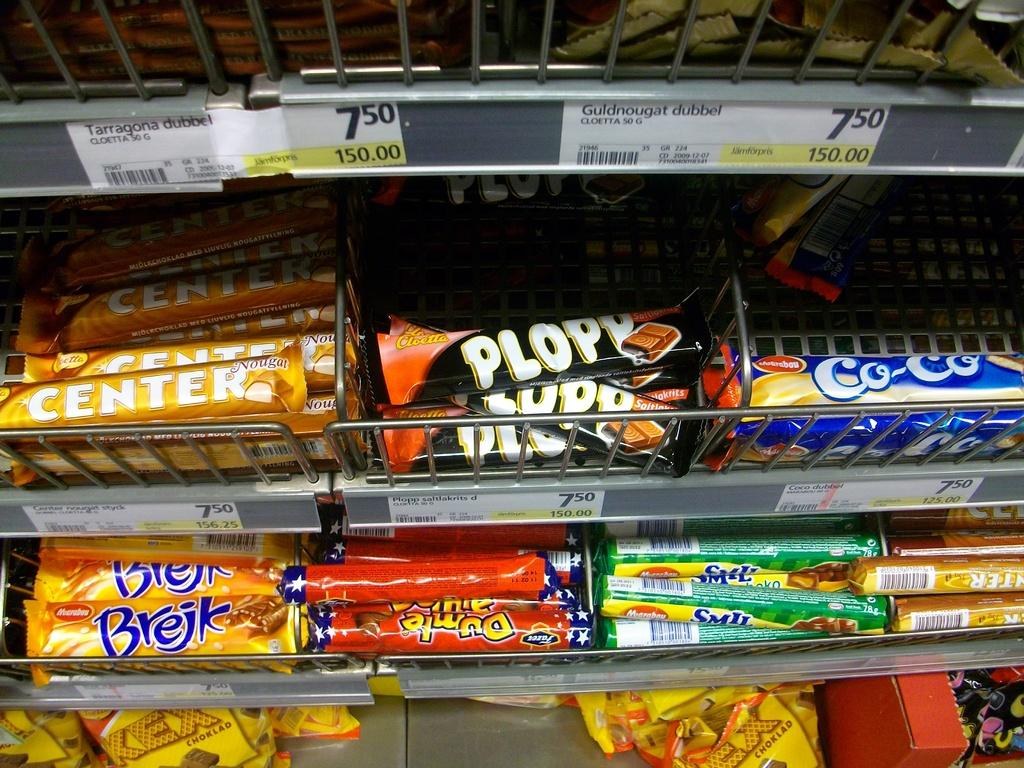<image>
Create a compact narrative representing the image presented. Grocery items neatly stacked in the shelf with brands names Center, plopp, co-co and brejk. 